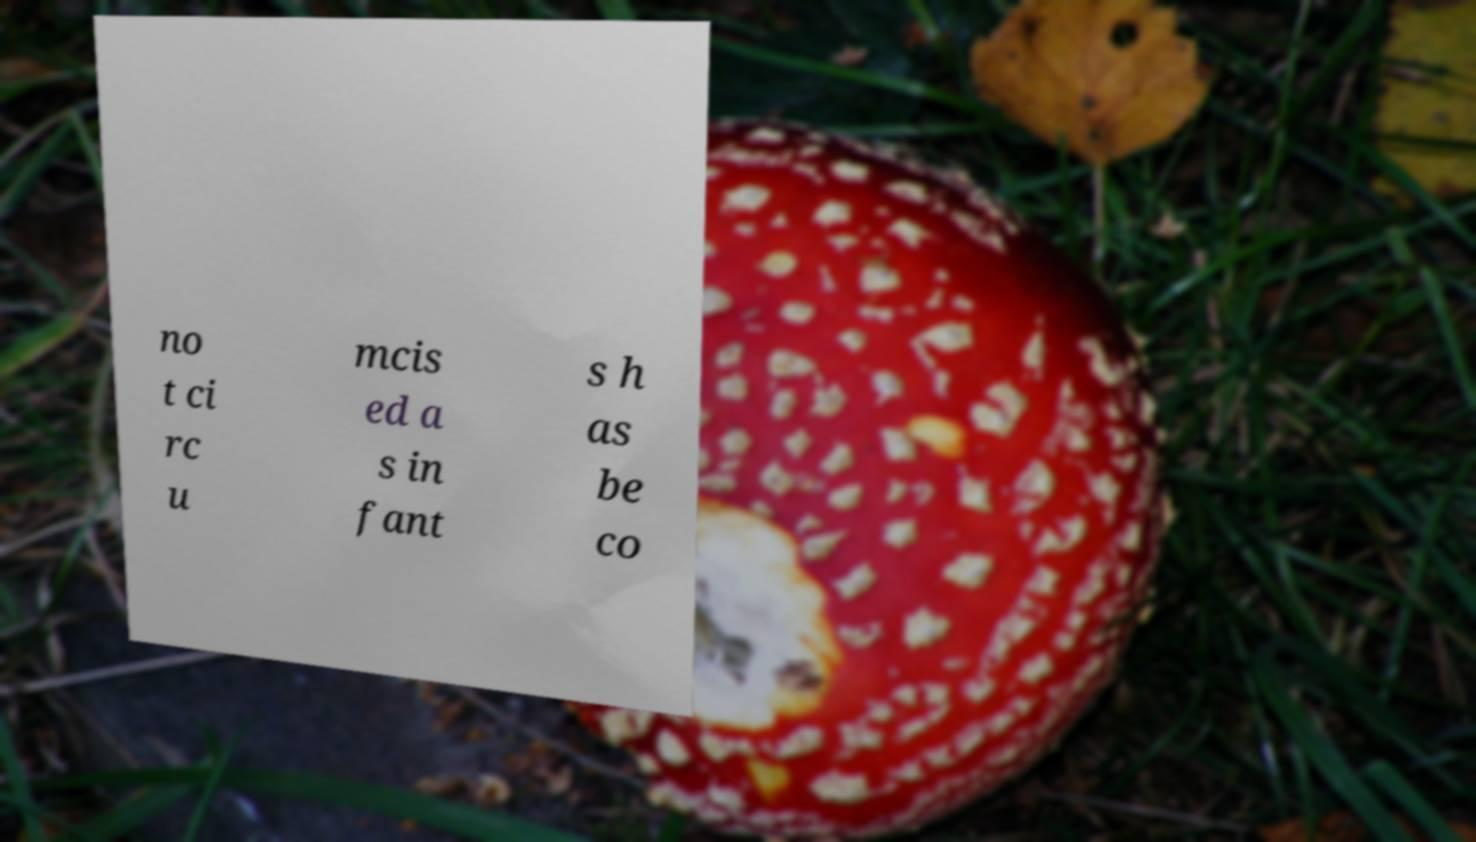What messages or text are displayed in this image? I need them in a readable, typed format. no t ci rc u mcis ed a s in fant s h as be co 